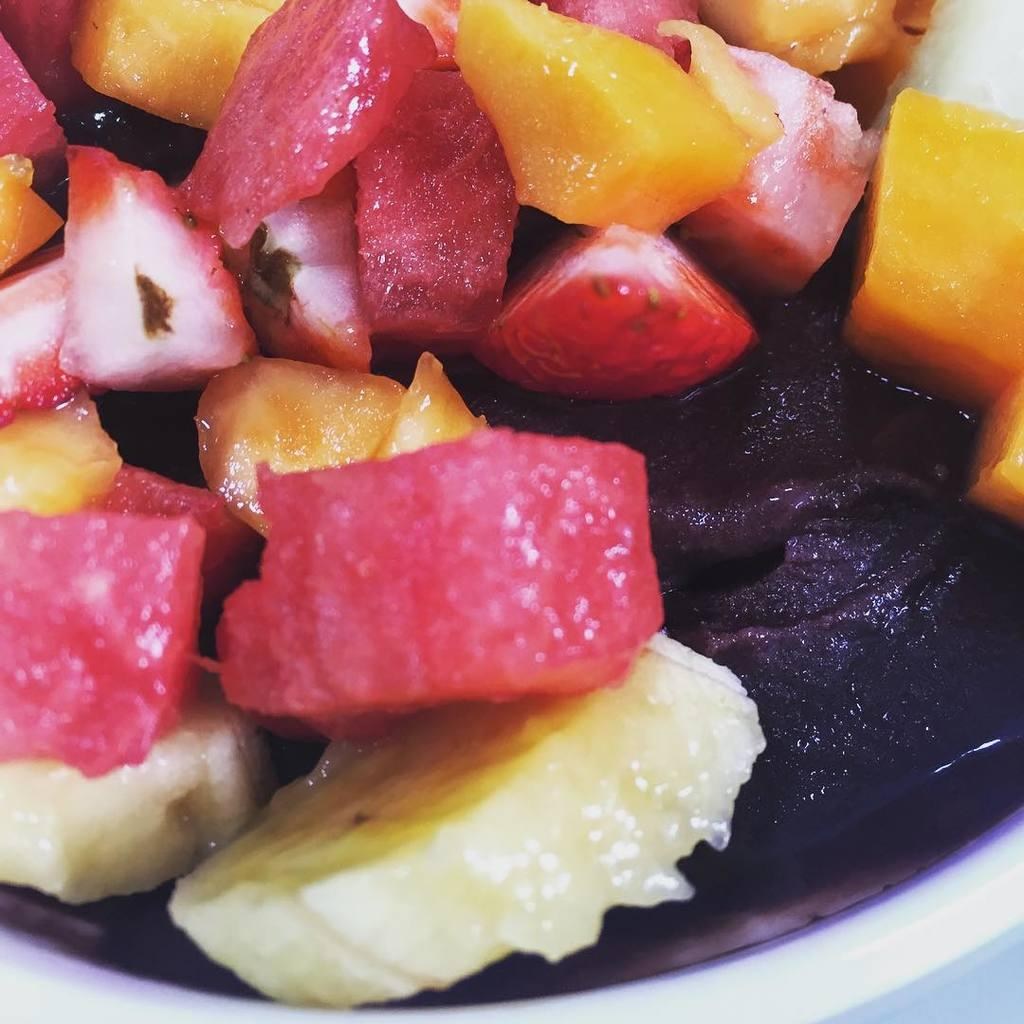What type of objects can be seen in the image? There are food items in the image. Where are the food items located? The food items are in a white color object. Can you see a rose in the image? There is no rose present in the image. 